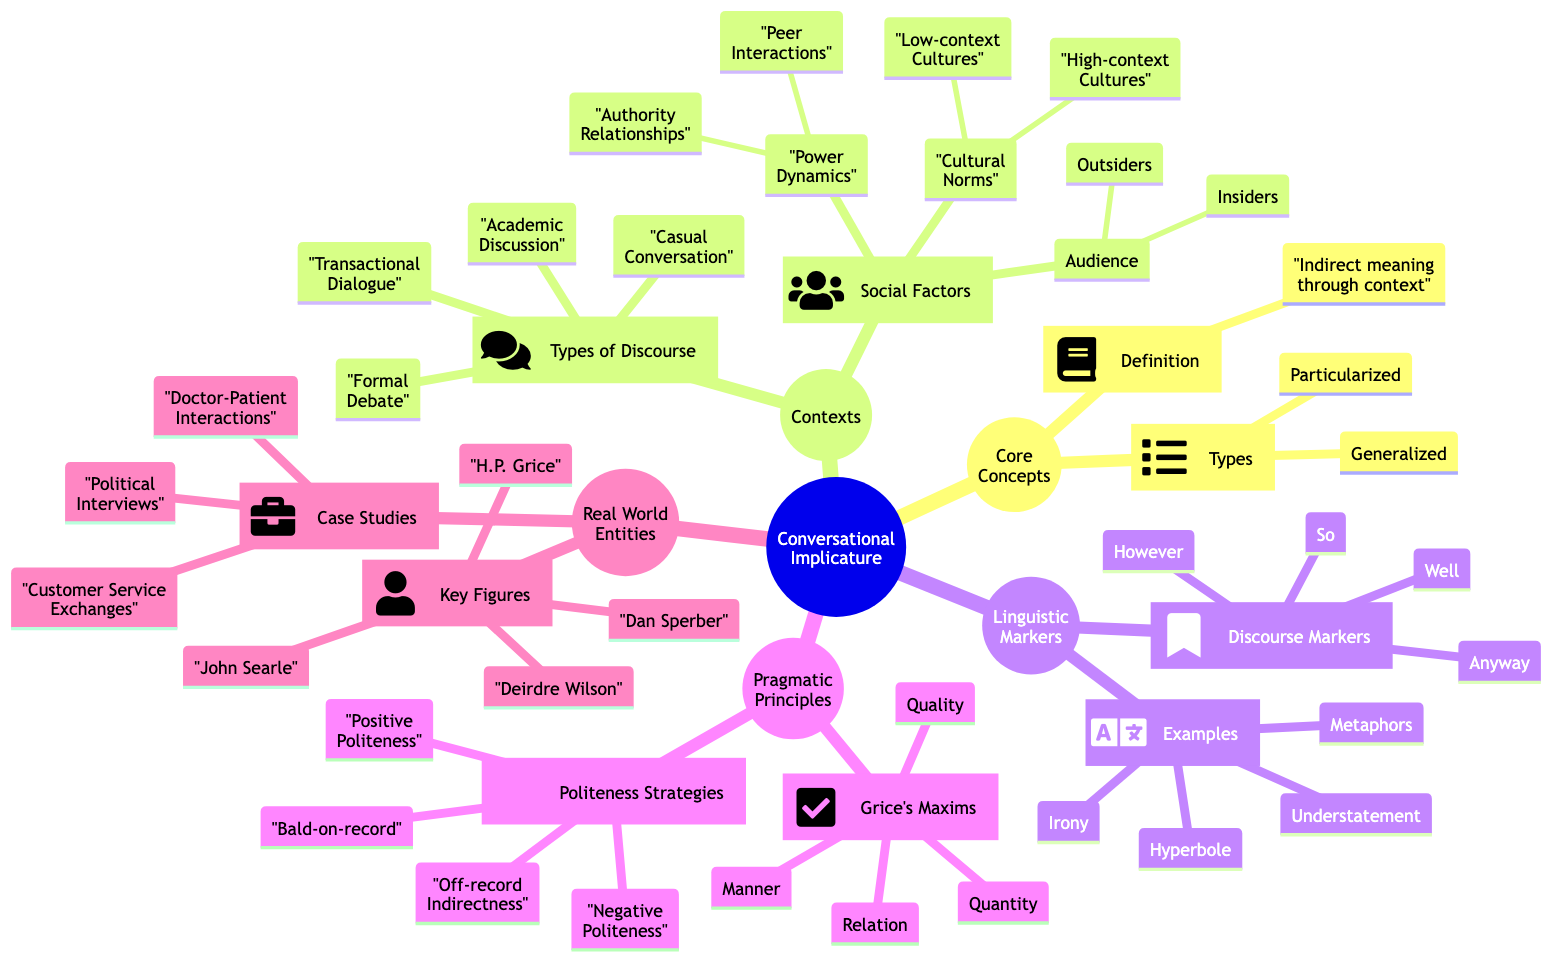What are the two types of conversational implicature? The diagram directly lists the types under the core concept of Conversational Implicature, which are Generalized Implicature and Particularized Implicature.
Answer: Generalized Implicature, Particularized Implicature How many types of discourse are mentioned? The diagram specifies the types under the context section labeled "Types of Discourse," which includes four examples: Casual Conversation, Formal Debate, Academic Discussion, and Transactional Dialogue.
Answer: 4 What factors are included under Social Factors? The diagram outlines two main categories under Social Factors: Power Dynamics and Cultural Norms, along with Audience. Each of these categories further includes specific elements.
Answer: Power Dynamics, Cultural Norms, Audience Which linguistic marker is associated with irony? The Examples section under Linguistic Markers lists Irony among other examples, indicating it as a type of linguistic marker conveying conversational implicature.
Answer: Irony What are the four Grice's Maxims listed in the diagram? The diagram enumerates the Grice's Maxims under the Pragmatic Principles section: Maxim of Quantity, Maxim of Quality, Maxim of Relation, and Maxim of Manner.
Answer: Maxim of Quantity, Maxim of Quality, Maxim of Relation, Maxim of Manner How does Politeness strategies relate to Grice's Maxims? The diagram features two main subcategories in Pragmatic Principles, Politeness Strategies and Grice's Maxims. This implies a relationship where both categories guide how implicature is constructed in conversations.
Answer: They guide conversational implicature What case studies are associated with conversational implicature? The Case Studies section under Real World Entities lists specific contexts such as Doctor-Patient Interactions, Customer Service Exchanges, and Political Interviews, showing practical applications of conversational implicature.
Answer: Doctor-Patient Interactions, Customer Service Exchanges, Political Interviews Which key figure is known for Grice's theory on implicature? The diagram indicates that H.P. Grice is listed as one of the key figures in the Real World Entities section, known for defining conversational implicature.
Answer: H.P. Grice How many social factors are identified in the diagram? The Social Factors part describes three main categories: Power Dynamics, Cultural Norms, and Audience. These are the overarching categories that display the complexity of social factors influencing implicature.
Answer: 3 What are the audiences mentioned in the context of conversational implicature? The Audience section under Social Factors directly lists Insiders and Outsiders as the two categories of audiences considered in conversational implicature.
Answer: Insiders, Outsiders 